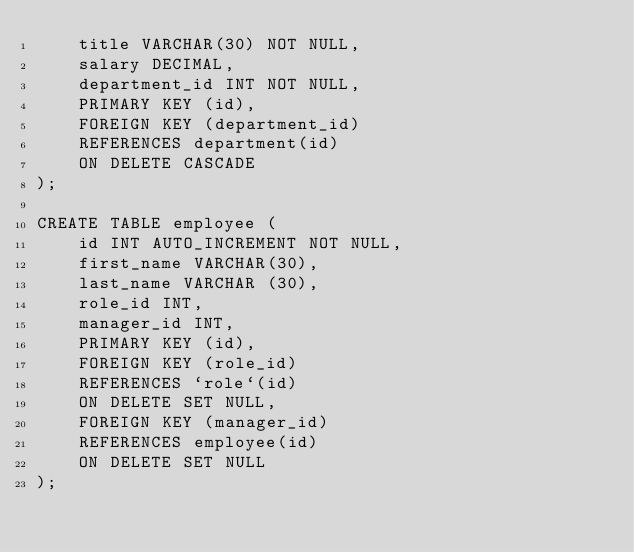Convert code to text. <code><loc_0><loc_0><loc_500><loc_500><_SQL_>    title VARCHAR(30) NOT NULL,
    salary DECIMAL,
    department_id INT NOT NULL,
    PRIMARY KEY (id),
    FOREIGN KEY (department_id)
    REFERENCES department(id)
    ON DELETE CASCADE
);

CREATE TABLE employee (
    id INT AUTO_INCREMENT NOT NULL,
    first_name VARCHAR(30),
    last_name VARCHAR (30),
    role_id INT,
    manager_id INT,
    PRIMARY KEY (id),
    FOREIGN KEY (role_id)
    REFERENCES `role`(id)
    ON DELETE SET NULL,
    FOREIGN KEY (manager_id)
    REFERENCES employee(id)
    ON DELETE SET NULL
);</code> 